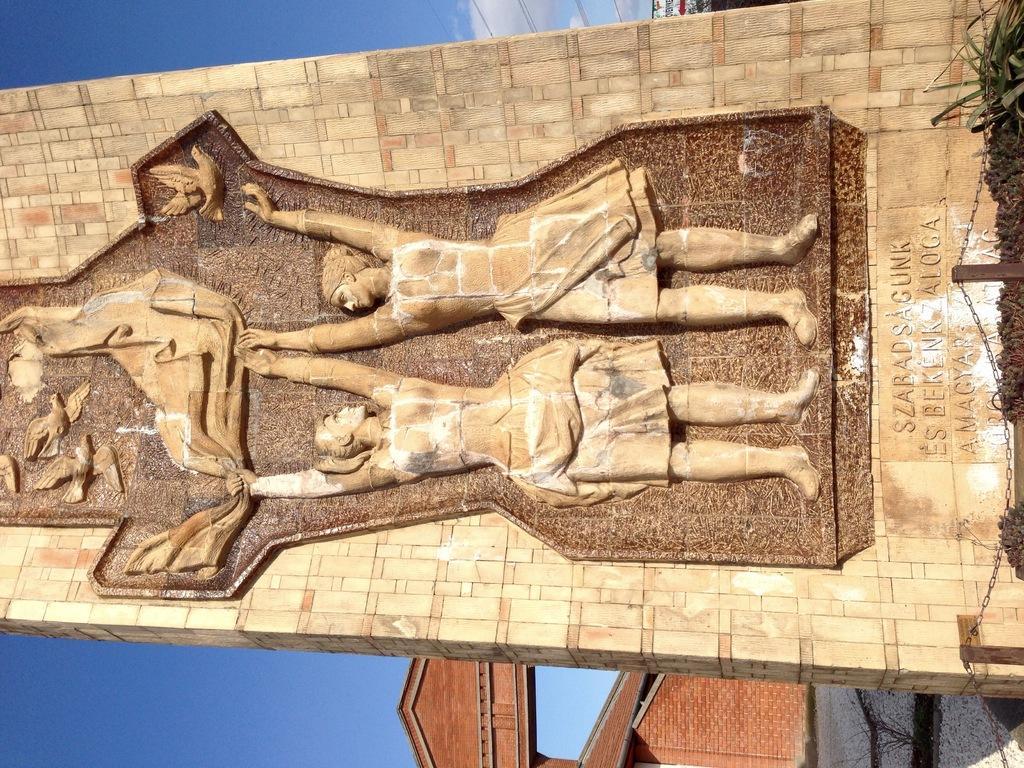How would you summarize this image in a sentence or two? In this image there is one monument in middle of this image and there is some text written at right side of this image and there is one building in the background and there is a sky at left side of this image. 